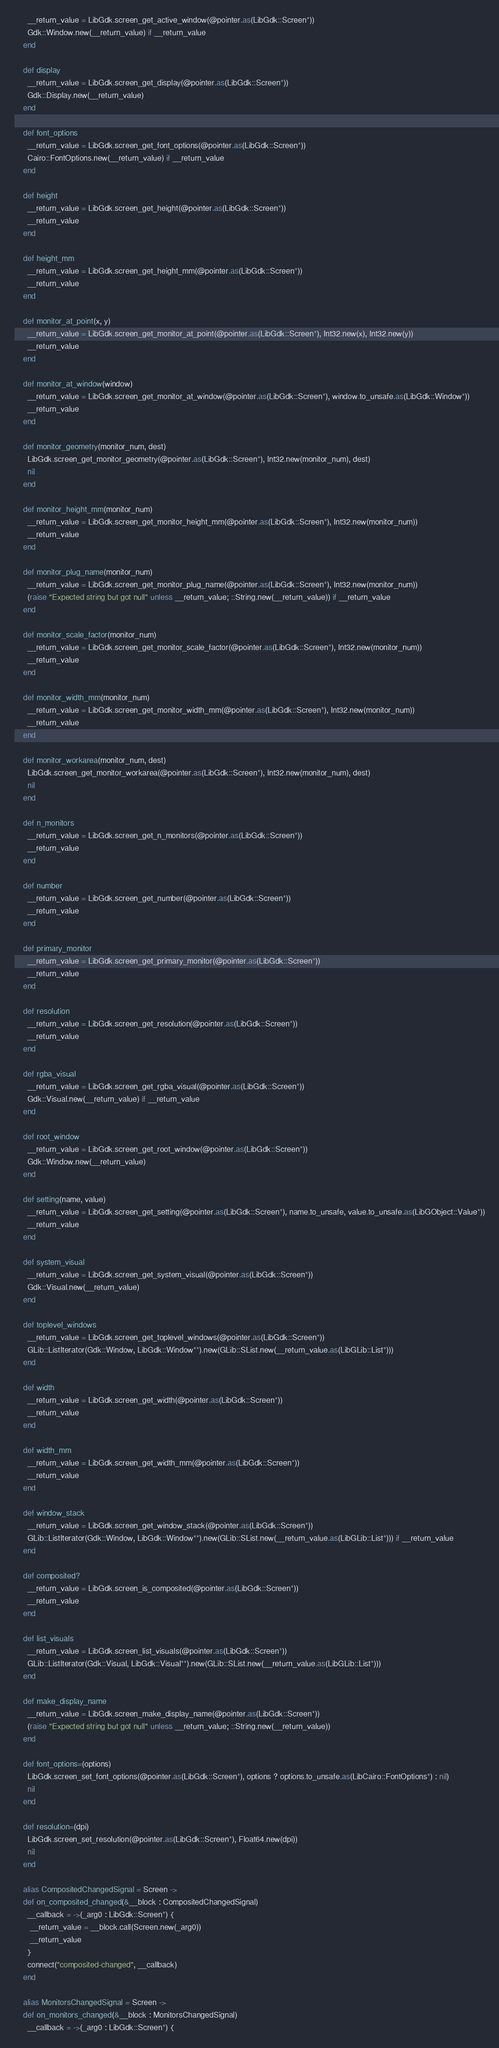<code> <loc_0><loc_0><loc_500><loc_500><_Crystal_>      __return_value = LibGdk.screen_get_active_window(@pointer.as(LibGdk::Screen*))
      Gdk::Window.new(__return_value) if __return_value
    end

    def display
      __return_value = LibGdk.screen_get_display(@pointer.as(LibGdk::Screen*))
      Gdk::Display.new(__return_value)
    end

    def font_options
      __return_value = LibGdk.screen_get_font_options(@pointer.as(LibGdk::Screen*))
      Cairo::FontOptions.new(__return_value) if __return_value
    end

    def height
      __return_value = LibGdk.screen_get_height(@pointer.as(LibGdk::Screen*))
      __return_value
    end

    def height_mm
      __return_value = LibGdk.screen_get_height_mm(@pointer.as(LibGdk::Screen*))
      __return_value
    end

    def monitor_at_point(x, y)
      __return_value = LibGdk.screen_get_monitor_at_point(@pointer.as(LibGdk::Screen*), Int32.new(x), Int32.new(y))
      __return_value
    end

    def monitor_at_window(window)
      __return_value = LibGdk.screen_get_monitor_at_window(@pointer.as(LibGdk::Screen*), window.to_unsafe.as(LibGdk::Window*))
      __return_value
    end

    def monitor_geometry(monitor_num, dest)
      LibGdk.screen_get_monitor_geometry(@pointer.as(LibGdk::Screen*), Int32.new(monitor_num), dest)
      nil
    end

    def monitor_height_mm(monitor_num)
      __return_value = LibGdk.screen_get_monitor_height_mm(@pointer.as(LibGdk::Screen*), Int32.new(monitor_num))
      __return_value
    end

    def monitor_plug_name(monitor_num)
      __return_value = LibGdk.screen_get_monitor_plug_name(@pointer.as(LibGdk::Screen*), Int32.new(monitor_num))
      (raise "Expected string but got null" unless __return_value; ::String.new(__return_value)) if __return_value
    end

    def monitor_scale_factor(monitor_num)
      __return_value = LibGdk.screen_get_monitor_scale_factor(@pointer.as(LibGdk::Screen*), Int32.new(monitor_num))
      __return_value
    end

    def monitor_width_mm(monitor_num)
      __return_value = LibGdk.screen_get_monitor_width_mm(@pointer.as(LibGdk::Screen*), Int32.new(monitor_num))
      __return_value
    end

    def monitor_workarea(monitor_num, dest)
      LibGdk.screen_get_monitor_workarea(@pointer.as(LibGdk::Screen*), Int32.new(monitor_num), dest)
      nil
    end

    def n_monitors
      __return_value = LibGdk.screen_get_n_monitors(@pointer.as(LibGdk::Screen*))
      __return_value
    end

    def number
      __return_value = LibGdk.screen_get_number(@pointer.as(LibGdk::Screen*))
      __return_value
    end

    def primary_monitor
      __return_value = LibGdk.screen_get_primary_monitor(@pointer.as(LibGdk::Screen*))
      __return_value
    end

    def resolution
      __return_value = LibGdk.screen_get_resolution(@pointer.as(LibGdk::Screen*))
      __return_value
    end

    def rgba_visual
      __return_value = LibGdk.screen_get_rgba_visual(@pointer.as(LibGdk::Screen*))
      Gdk::Visual.new(__return_value) if __return_value
    end

    def root_window
      __return_value = LibGdk.screen_get_root_window(@pointer.as(LibGdk::Screen*))
      Gdk::Window.new(__return_value)
    end

    def setting(name, value)
      __return_value = LibGdk.screen_get_setting(@pointer.as(LibGdk::Screen*), name.to_unsafe, value.to_unsafe.as(LibGObject::Value*))
      __return_value
    end

    def system_visual
      __return_value = LibGdk.screen_get_system_visual(@pointer.as(LibGdk::Screen*))
      Gdk::Visual.new(__return_value)
    end

    def toplevel_windows
      __return_value = LibGdk.screen_get_toplevel_windows(@pointer.as(LibGdk::Screen*))
      GLib::ListIterator(Gdk::Window, LibGdk::Window**).new(GLib::SList.new(__return_value.as(LibGLib::List*)))
    end

    def width
      __return_value = LibGdk.screen_get_width(@pointer.as(LibGdk::Screen*))
      __return_value
    end

    def width_mm
      __return_value = LibGdk.screen_get_width_mm(@pointer.as(LibGdk::Screen*))
      __return_value
    end

    def window_stack
      __return_value = LibGdk.screen_get_window_stack(@pointer.as(LibGdk::Screen*))
      GLib::ListIterator(Gdk::Window, LibGdk::Window**).new(GLib::SList.new(__return_value.as(LibGLib::List*))) if __return_value
    end

    def composited?
      __return_value = LibGdk.screen_is_composited(@pointer.as(LibGdk::Screen*))
      __return_value
    end

    def list_visuals
      __return_value = LibGdk.screen_list_visuals(@pointer.as(LibGdk::Screen*))
      GLib::ListIterator(Gdk::Visual, LibGdk::Visual**).new(GLib::SList.new(__return_value.as(LibGLib::List*)))
    end

    def make_display_name
      __return_value = LibGdk.screen_make_display_name(@pointer.as(LibGdk::Screen*))
      (raise "Expected string but got null" unless __return_value; ::String.new(__return_value))
    end

    def font_options=(options)
      LibGdk.screen_set_font_options(@pointer.as(LibGdk::Screen*), options ? options.to_unsafe.as(LibCairo::FontOptions*) : nil)
      nil
    end

    def resolution=(dpi)
      LibGdk.screen_set_resolution(@pointer.as(LibGdk::Screen*), Float64.new(dpi))
      nil
    end

    alias CompositedChangedSignal = Screen ->
    def on_composited_changed(&__block : CompositedChangedSignal)
      __callback = ->(_arg0 : LibGdk::Screen*) {
       __return_value = __block.call(Screen.new(_arg0))
       __return_value
      }
      connect("composited-changed", __callback)
    end

    alias MonitorsChangedSignal = Screen ->
    def on_monitors_changed(&__block : MonitorsChangedSignal)
      __callback = ->(_arg0 : LibGdk::Screen*) {</code> 